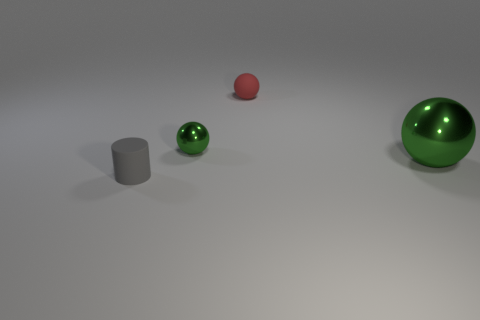Does the red rubber thing have the same shape as the thing that is right of the red sphere?
Provide a succinct answer. Yes. How many other things are there of the same size as the red object?
Provide a succinct answer. 2. What number of green things are either small metallic things or big metallic cylinders?
Keep it short and to the point. 1. What number of small things are both to the right of the tiny gray object and to the left of the red thing?
Give a very brief answer. 1. What material is the cylinder that is left of the rubber object that is to the right of the matte object that is in front of the big shiny thing?
Your response must be concise. Rubber. How many small gray things have the same material as the tiny red thing?
Keep it short and to the point. 1. What shape is the large thing that is the same color as the small metallic object?
Ensure brevity in your answer.  Sphere. What is the shape of the other rubber object that is the same size as the red rubber object?
Provide a short and direct response. Cylinder. Are there any things on the right side of the red matte object?
Your answer should be very brief. Yes. Are there any other green objects that have the same shape as the large metallic thing?
Make the answer very short. Yes. 